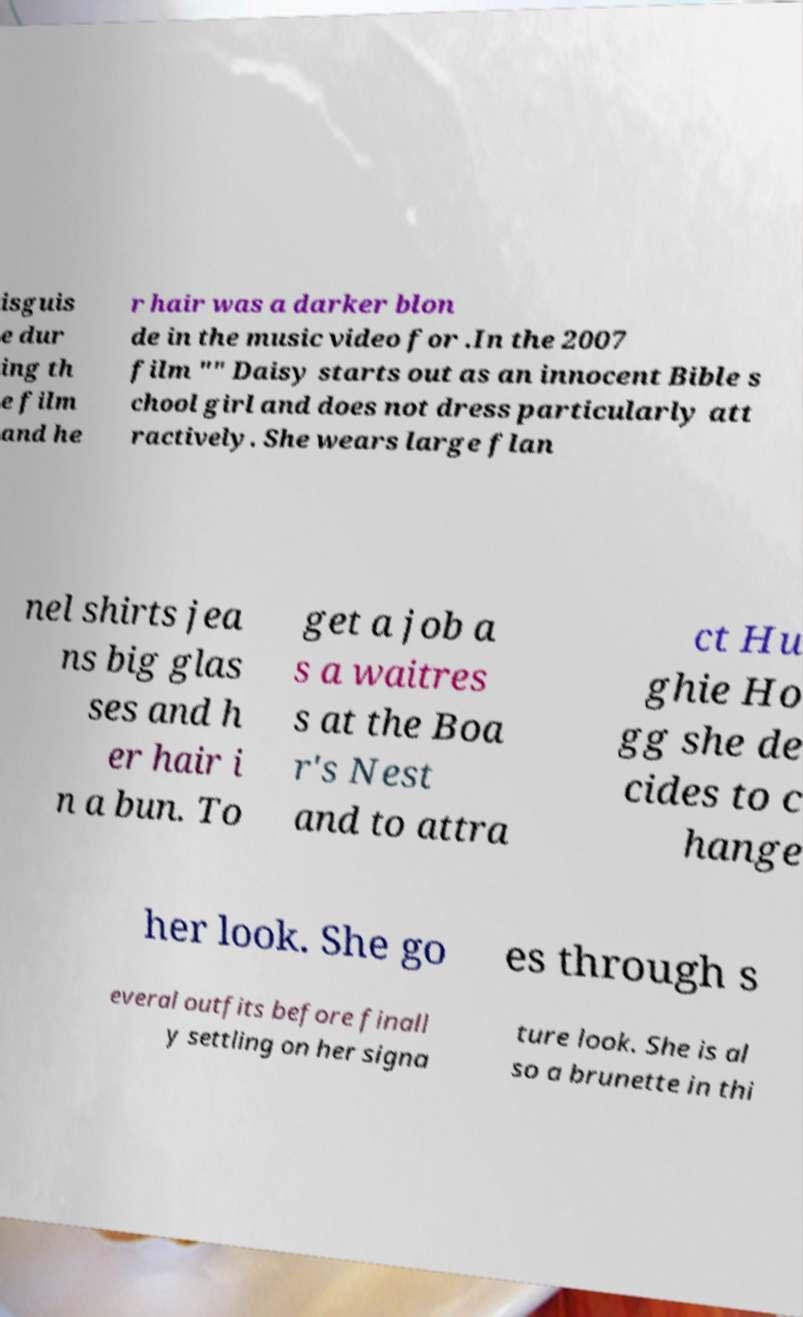There's text embedded in this image that I need extracted. Can you transcribe it verbatim? isguis e dur ing th e film and he r hair was a darker blon de in the music video for .In the 2007 film "" Daisy starts out as an innocent Bible s chool girl and does not dress particularly att ractively. She wears large flan nel shirts jea ns big glas ses and h er hair i n a bun. To get a job a s a waitres s at the Boa r's Nest and to attra ct Hu ghie Ho gg she de cides to c hange her look. She go es through s everal outfits before finall y settling on her signa ture look. She is al so a brunette in thi 